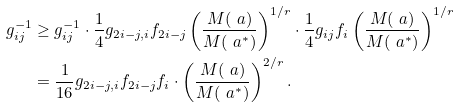<formula> <loc_0><loc_0><loc_500><loc_500>g _ { i j } ^ { - 1 } & \geq g _ { i j } ^ { - 1 } \cdot \frac { 1 } { 4 } g _ { 2 i - j , i } f _ { 2 i - j } \left ( \frac { M ( \ a ) } { M ( \ a ^ { * } ) } \right ) ^ { 1 / r } \cdot \frac { 1 } { 4 } g _ { i j } f _ { i } \left ( \frac { M ( \ a ) } { M ( \ a ^ { * } ) } \right ) ^ { 1 / r } \\ & = \frac { 1 } { 1 6 } g _ { 2 i - j , i } f _ { 2 i - j } f _ { i } \cdot \left ( \frac { M ( \ a ) } { M ( \ a ^ { * } ) } \right ) ^ { 2 / r } .</formula> 